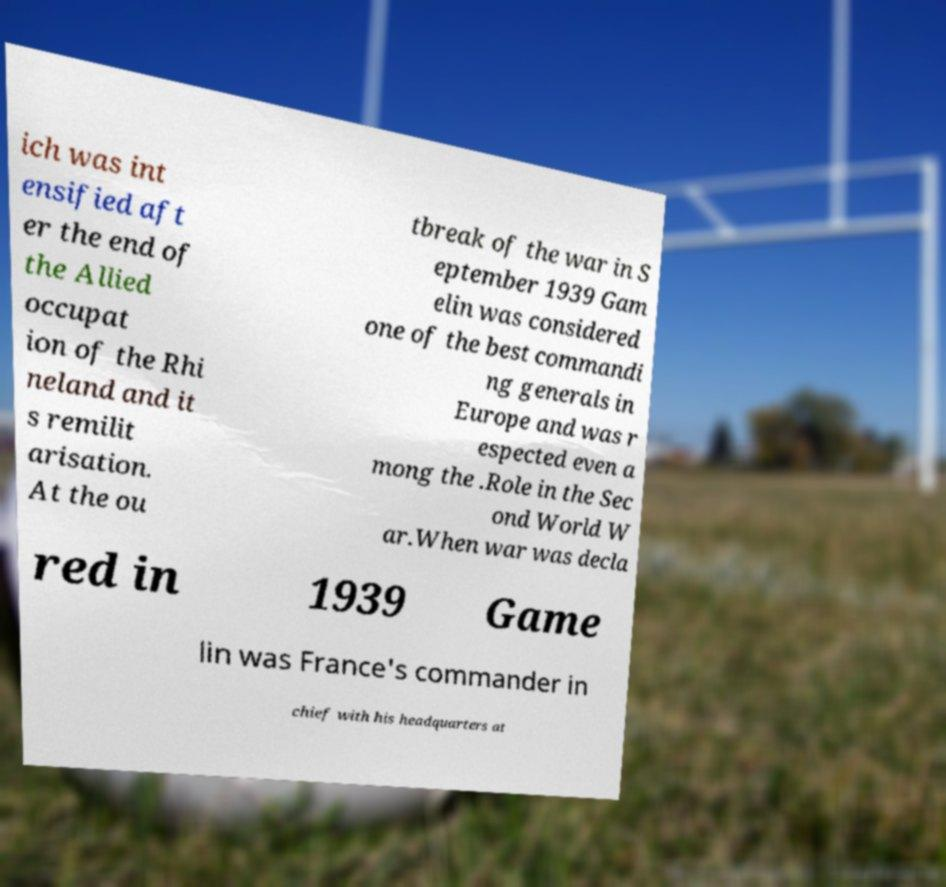I need the written content from this picture converted into text. Can you do that? ich was int ensified aft er the end of the Allied occupat ion of the Rhi neland and it s remilit arisation. At the ou tbreak of the war in S eptember 1939 Gam elin was considered one of the best commandi ng generals in Europe and was r espected even a mong the .Role in the Sec ond World W ar.When war was decla red in 1939 Game lin was France's commander in chief with his headquarters at 